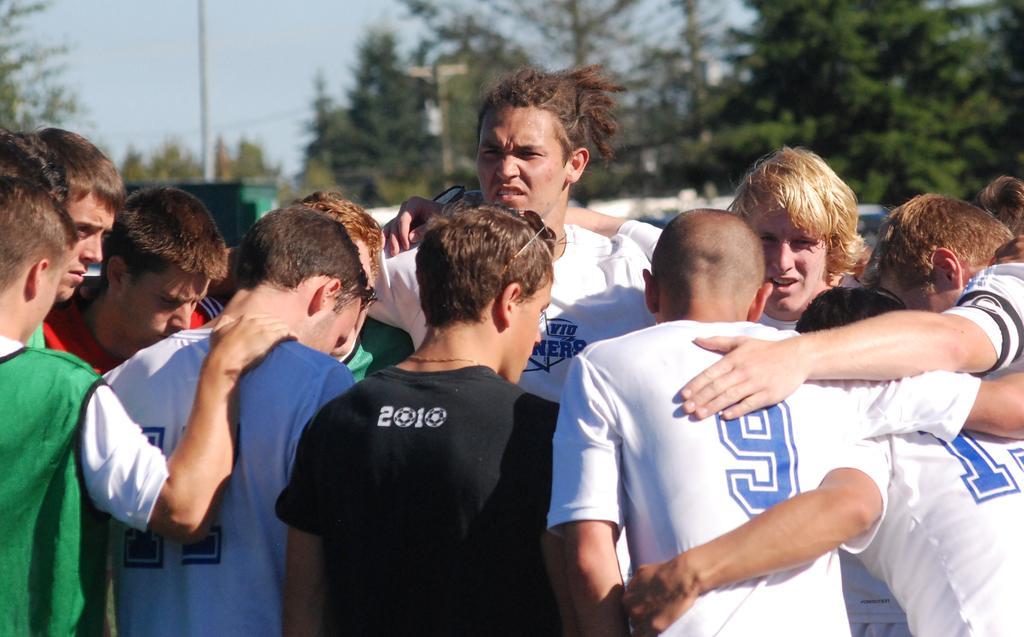Could you give a brief overview of what you see in this image? In this image I can see number of people are standing in the front and I can see all of them are wearing t shirts. In the background I can see number of trees, a pole and the sky. I can also see this image is little bit blurry in the background. 